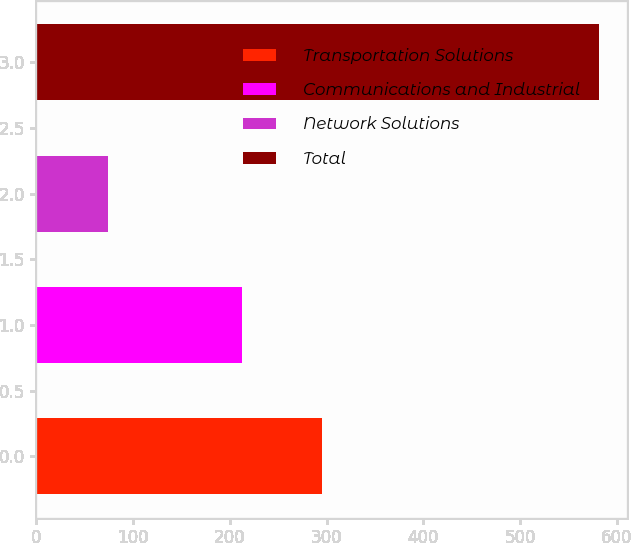Convert chart to OTSL. <chart><loc_0><loc_0><loc_500><loc_500><bar_chart><fcel>Transportation Solutions<fcel>Communications and Industrial<fcel>Network Solutions<fcel>Total<nl><fcel>295<fcel>212<fcel>74<fcel>581<nl></chart> 